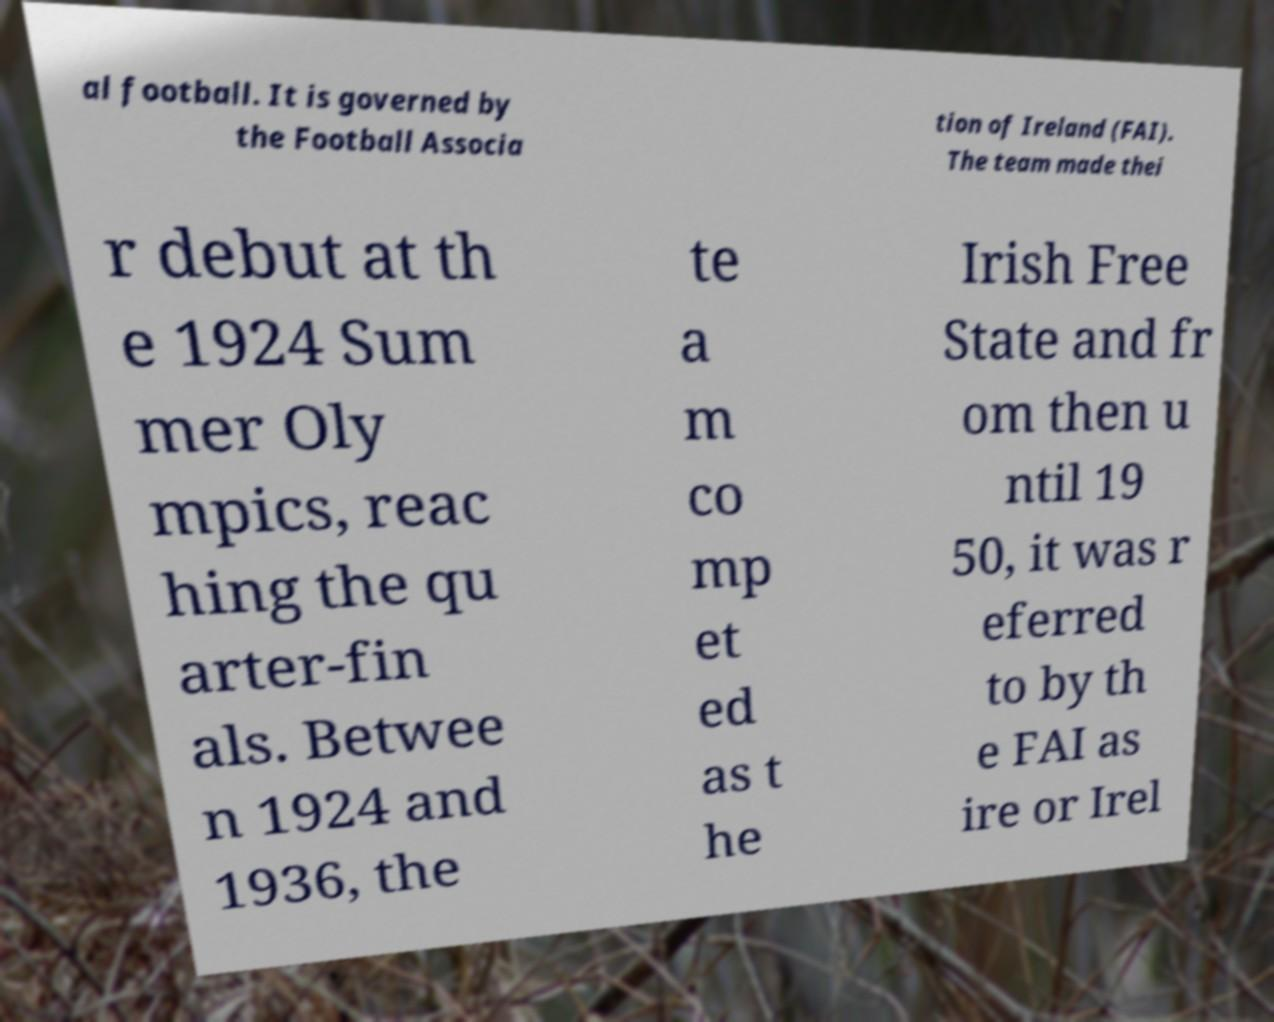Please identify and transcribe the text found in this image. al football. It is governed by the Football Associa tion of Ireland (FAI). The team made thei r debut at th e 1924 Sum mer Oly mpics, reac hing the qu arter-fin als. Betwee n 1924 and 1936, the te a m co mp et ed as t he Irish Free State and fr om then u ntil 19 50, it was r eferred to by th e FAI as ire or Irel 